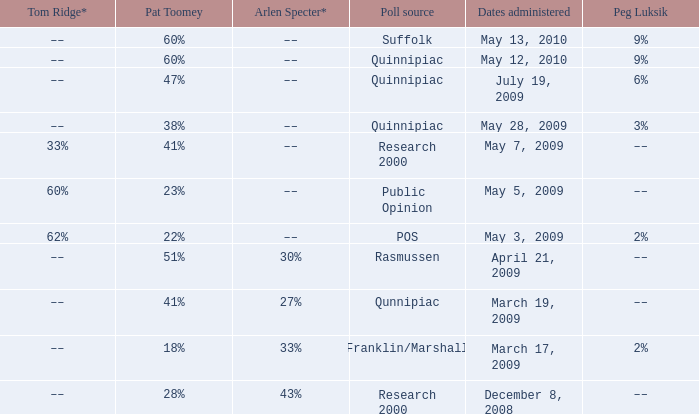Which Dates administered has an Arlen Specter* of ––, and a Peg Luksik of 9%? May 13, 2010, May 12, 2010. 